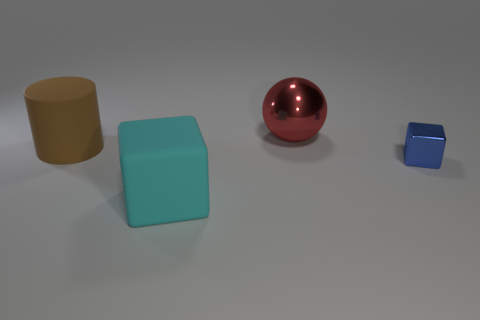Subtract all balls. How many objects are left? 3 Subtract all purple spheres. How many brown cubes are left? 0 Subtract 0 blue cylinders. How many objects are left? 4 Subtract 1 cylinders. How many cylinders are left? 0 Subtract all brown balls. Subtract all blue blocks. How many balls are left? 1 Subtract all large yellow things. Subtract all metal things. How many objects are left? 2 Add 2 balls. How many balls are left? 3 Add 2 brown rubber objects. How many brown rubber objects exist? 3 Add 4 large cyan blocks. How many objects exist? 8 